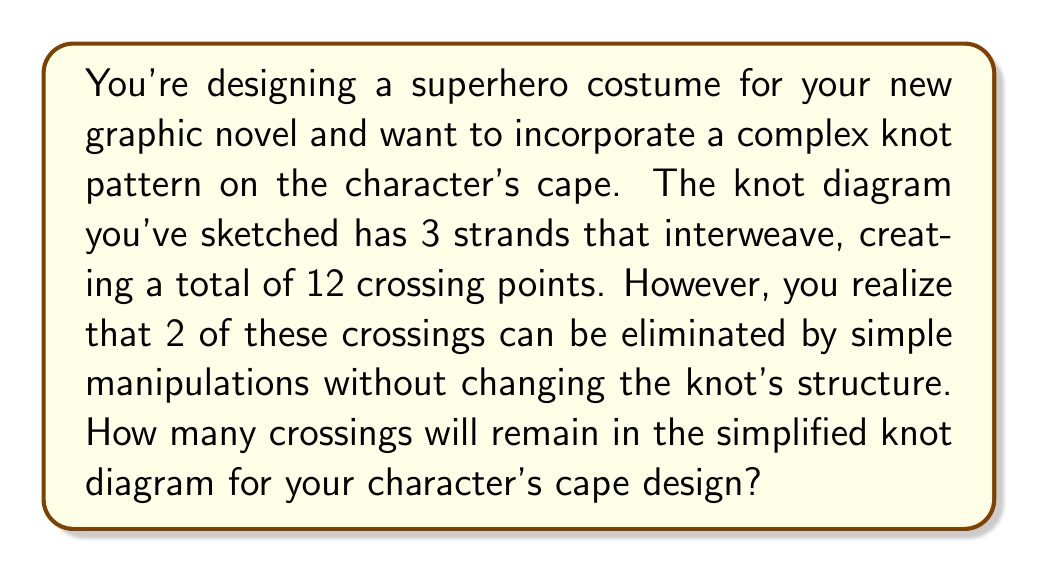What is the answer to this math problem? Let's approach this step-by-step:

1) We start with the initial number of crossings in the knot diagram:
   $$\text{Initial crossings} = 12$$

2) We're told that 2 crossings can be eliminated:
   $$\text{Eliminable crossings} = 2$$

3) To find the number of remaining crossings, we subtract the eliminable crossings from the initial crossings:

   $$\text{Remaining crossings} = \text{Initial crossings} - \text{Eliminable crossings}$$
   $$\text{Remaining crossings} = 12 - 2 = 10$$

Therefore, after simplification, the knot diagram for the character's cape design will have 10 crossings.
Answer: 10 crossings 